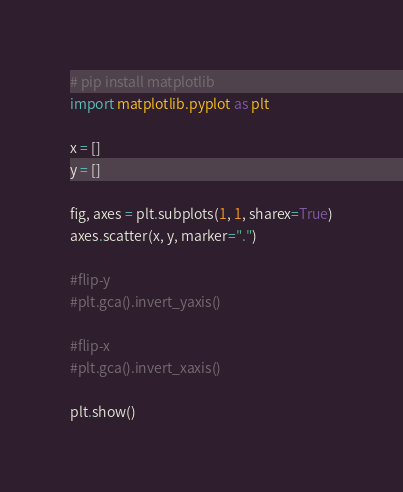Convert code to text. <code><loc_0><loc_0><loc_500><loc_500><_Python_># pip install matplotlib
import matplotlib.pyplot as plt

x = []
y = []

fig, axes = plt.subplots(1, 1, sharex=True)
axes.scatter(x, y, marker=".")

#flip-y
#plt.gca().invert_yaxis()

#flip-x
#plt.gca().invert_xaxis()

plt.show()</code> 